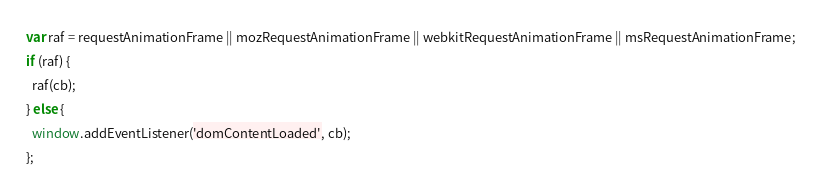<code> <loc_0><loc_0><loc_500><loc_500><_JavaScript_>var raf = requestAnimationFrame || mozRequestAnimationFrame || webkitRequestAnimationFrame || msRequestAnimationFrame;
if (raf) {
  raf(cb);
} else {
  window.addEventListener('domContentLoaded', cb);
};</code> 